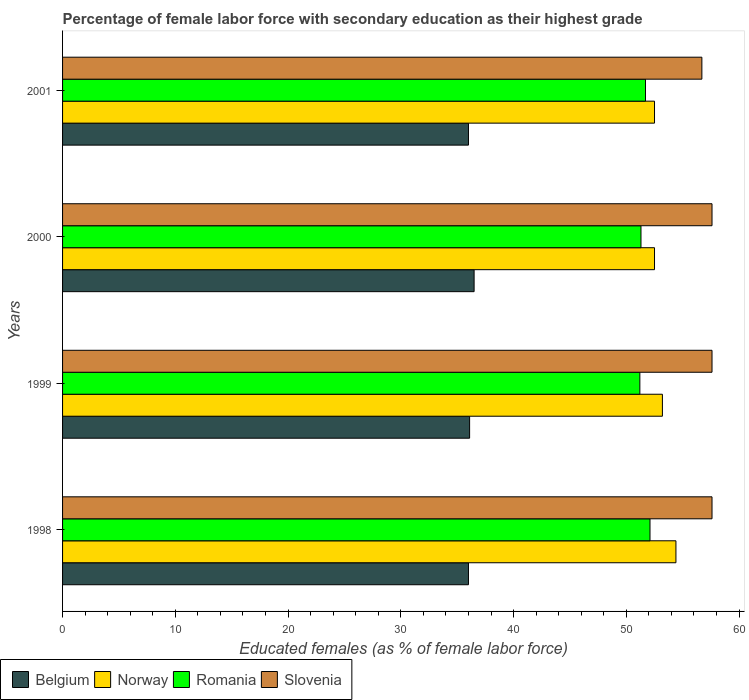How many different coloured bars are there?
Your answer should be very brief. 4. How many groups of bars are there?
Offer a terse response. 4. Are the number of bars per tick equal to the number of legend labels?
Your answer should be very brief. Yes. Are the number of bars on each tick of the Y-axis equal?
Your answer should be very brief. Yes. How many bars are there on the 1st tick from the top?
Your response must be concise. 4. How many bars are there on the 4th tick from the bottom?
Your answer should be compact. 4. What is the label of the 1st group of bars from the top?
Make the answer very short. 2001. In how many cases, is the number of bars for a given year not equal to the number of legend labels?
Keep it short and to the point. 0. What is the percentage of female labor force with secondary education in Romania in 1998?
Keep it short and to the point. 52.1. Across all years, what is the maximum percentage of female labor force with secondary education in Romania?
Make the answer very short. 52.1. Across all years, what is the minimum percentage of female labor force with secondary education in Slovenia?
Provide a short and direct response. 56.7. What is the total percentage of female labor force with secondary education in Romania in the graph?
Your answer should be very brief. 206.3. What is the difference between the percentage of female labor force with secondary education in Norway in 1999 and that in 2000?
Give a very brief answer. 0.7. What is the average percentage of female labor force with secondary education in Romania per year?
Give a very brief answer. 51.57. In the year 1999, what is the difference between the percentage of female labor force with secondary education in Romania and percentage of female labor force with secondary education in Norway?
Your answer should be compact. -2. In how many years, is the percentage of female labor force with secondary education in Romania greater than 40 %?
Provide a succinct answer. 4. What is the ratio of the percentage of female labor force with secondary education in Slovenia in 1999 to that in 2001?
Your answer should be compact. 1.02. Is the percentage of female labor force with secondary education in Norway in 1998 less than that in 2000?
Your answer should be very brief. No. Is the difference between the percentage of female labor force with secondary education in Romania in 1998 and 2001 greater than the difference between the percentage of female labor force with secondary education in Norway in 1998 and 2001?
Your response must be concise. No. What is the difference between the highest and the second highest percentage of female labor force with secondary education in Romania?
Offer a terse response. 0.4. What is the difference between the highest and the lowest percentage of female labor force with secondary education in Belgium?
Keep it short and to the point. 0.5. In how many years, is the percentage of female labor force with secondary education in Romania greater than the average percentage of female labor force with secondary education in Romania taken over all years?
Give a very brief answer. 2. Is the sum of the percentage of female labor force with secondary education in Belgium in 2000 and 2001 greater than the maximum percentage of female labor force with secondary education in Norway across all years?
Provide a short and direct response. Yes. What does the 4th bar from the bottom in 1998 represents?
Your answer should be compact. Slovenia. Are all the bars in the graph horizontal?
Keep it short and to the point. Yes. How many years are there in the graph?
Ensure brevity in your answer.  4. Are the values on the major ticks of X-axis written in scientific E-notation?
Make the answer very short. No. Does the graph contain any zero values?
Make the answer very short. No. Where does the legend appear in the graph?
Your answer should be compact. Bottom left. How many legend labels are there?
Your answer should be very brief. 4. What is the title of the graph?
Your answer should be very brief. Percentage of female labor force with secondary education as their highest grade. Does "St. Kitts and Nevis" appear as one of the legend labels in the graph?
Keep it short and to the point. No. What is the label or title of the X-axis?
Provide a succinct answer. Educated females (as % of female labor force). What is the label or title of the Y-axis?
Make the answer very short. Years. What is the Educated females (as % of female labor force) in Belgium in 1998?
Your answer should be very brief. 36. What is the Educated females (as % of female labor force) in Norway in 1998?
Offer a terse response. 54.4. What is the Educated females (as % of female labor force) of Romania in 1998?
Give a very brief answer. 52.1. What is the Educated females (as % of female labor force) of Slovenia in 1998?
Provide a short and direct response. 57.6. What is the Educated females (as % of female labor force) of Belgium in 1999?
Your answer should be very brief. 36.1. What is the Educated females (as % of female labor force) in Norway in 1999?
Make the answer very short. 53.2. What is the Educated females (as % of female labor force) in Romania in 1999?
Your response must be concise. 51.2. What is the Educated females (as % of female labor force) in Slovenia in 1999?
Provide a short and direct response. 57.6. What is the Educated females (as % of female labor force) of Belgium in 2000?
Offer a terse response. 36.5. What is the Educated females (as % of female labor force) of Norway in 2000?
Your response must be concise. 52.5. What is the Educated females (as % of female labor force) in Romania in 2000?
Your response must be concise. 51.3. What is the Educated females (as % of female labor force) in Slovenia in 2000?
Your answer should be compact. 57.6. What is the Educated females (as % of female labor force) of Norway in 2001?
Make the answer very short. 52.5. What is the Educated females (as % of female labor force) of Romania in 2001?
Your answer should be compact. 51.7. What is the Educated females (as % of female labor force) of Slovenia in 2001?
Ensure brevity in your answer.  56.7. Across all years, what is the maximum Educated females (as % of female labor force) of Belgium?
Give a very brief answer. 36.5. Across all years, what is the maximum Educated females (as % of female labor force) in Norway?
Your answer should be compact. 54.4. Across all years, what is the maximum Educated females (as % of female labor force) in Romania?
Make the answer very short. 52.1. Across all years, what is the maximum Educated females (as % of female labor force) in Slovenia?
Your response must be concise. 57.6. Across all years, what is the minimum Educated females (as % of female labor force) of Belgium?
Provide a short and direct response. 36. Across all years, what is the minimum Educated females (as % of female labor force) of Norway?
Ensure brevity in your answer.  52.5. Across all years, what is the minimum Educated females (as % of female labor force) in Romania?
Your response must be concise. 51.2. Across all years, what is the minimum Educated females (as % of female labor force) in Slovenia?
Offer a terse response. 56.7. What is the total Educated females (as % of female labor force) of Belgium in the graph?
Provide a succinct answer. 144.6. What is the total Educated females (as % of female labor force) in Norway in the graph?
Make the answer very short. 212.6. What is the total Educated females (as % of female labor force) of Romania in the graph?
Keep it short and to the point. 206.3. What is the total Educated females (as % of female labor force) in Slovenia in the graph?
Give a very brief answer. 229.5. What is the difference between the Educated females (as % of female labor force) in Romania in 1998 and that in 1999?
Your response must be concise. 0.9. What is the difference between the Educated females (as % of female labor force) of Norway in 1998 and that in 2000?
Make the answer very short. 1.9. What is the difference between the Educated females (as % of female labor force) of Romania in 1998 and that in 2000?
Ensure brevity in your answer.  0.8. What is the difference between the Educated females (as % of female labor force) of Belgium in 1998 and that in 2001?
Your answer should be very brief. 0. What is the difference between the Educated females (as % of female labor force) in Slovenia in 1998 and that in 2001?
Provide a short and direct response. 0.9. What is the difference between the Educated females (as % of female labor force) in Romania in 1999 and that in 2000?
Provide a short and direct response. -0.1. What is the difference between the Educated females (as % of female labor force) in Norway in 1999 and that in 2001?
Give a very brief answer. 0.7. What is the difference between the Educated females (as % of female labor force) of Romania in 1999 and that in 2001?
Offer a terse response. -0.5. What is the difference between the Educated females (as % of female labor force) of Slovenia in 2000 and that in 2001?
Your answer should be compact. 0.9. What is the difference between the Educated females (as % of female labor force) in Belgium in 1998 and the Educated females (as % of female labor force) in Norway in 1999?
Give a very brief answer. -17.2. What is the difference between the Educated females (as % of female labor force) in Belgium in 1998 and the Educated females (as % of female labor force) in Romania in 1999?
Offer a very short reply. -15.2. What is the difference between the Educated females (as % of female labor force) in Belgium in 1998 and the Educated females (as % of female labor force) in Slovenia in 1999?
Offer a very short reply. -21.6. What is the difference between the Educated females (as % of female labor force) in Norway in 1998 and the Educated females (as % of female labor force) in Slovenia in 1999?
Your response must be concise. -3.2. What is the difference between the Educated females (as % of female labor force) in Belgium in 1998 and the Educated females (as % of female labor force) in Norway in 2000?
Give a very brief answer. -16.5. What is the difference between the Educated females (as % of female labor force) of Belgium in 1998 and the Educated females (as % of female labor force) of Romania in 2000?
Offer a very short reply. -15.3. What is the difference between the Educated females (as % of female labor force) of Belgium in 1998 and the Educated females (as % of female labor force) of Slovenia in 2000?
Offer a very short reply. -21.6. What is the difference between the Educated females (as % of female labor force) of Norway in 1998 and the Educated females (as % of female labor force) of Romania in 2000?
Make the answer very short. 3.1. What is the difference between the Educated females (as % of female labor force) of Romania in 1998 and the Educated females (as % of female labor force) of Slovenia in 2000?
Your response must be concise. -5.5. What is the difference between the Educated females (as % of female labor force) in Belgium in 1998 and the Educated females (as % of female labor force) in Norway in 2001?
Make the answer very short. -16.5. What is the difference between the Educated females (as % of female labor force) in Belgium in 1998 and the Educated females (as % of female labor force) in Romania in 2001?
Provide a succinct answer. -15.7. What is the difference between the Educated females (as % of female labor force) in Belgium in 1998 and the Educated females (as % of female labor force) in Slovenia in 2001?
Make the answer very short. -20.7. What is the difference between the Educated females (as % of female labor force) of Belgium in 1999 and the Educated females (as % of female labor force) of Norway in 2000?
Ensure brevity in your answer.  -16.4. What is the difference between the Educated females (as % of female labor force) of Belgium in 1999 and the Educated females (as % of female labor force) of Romania in 2000?
Ensure brevity in your answer.  -15.2. What is the difference between the Educated females (as % of female labor force) in Belgium in 1999 and the Educated females (as % of female labor force) in Slovenia in 2000?
Provide a short and direct response. -21.5. What is the difference between the Educated females (as % of female labor force) in Norway in 1999 and the Educated females (as % of female labor force) in Slovenia in 2000?
Your response must be concise. -4.4. What is the difference between the Educated females (as % of female labor force) in Belgium in 1999 and the Educated females (as % of female labor force) in Norway in 2001?
Keep it short and to the point. -16.4. What is the difference between the Educated females (as % of female labor force) of Belgium in 1999 and the Educated females (as % of female labor force) of Romania in 2001?
Offer a terse response. -15.6. What is the difference between the Educated females (as % of female labor force) in Belgium in 1999 and the Educated females (as % of female labor force) in Slovenia in 2001?
Keep it short and to the point. -20.6. What is the difference between the Educated females (as % of female labor force) in Norway in 1999 and the Educated females (as % of female labor force) in Romania in 2001?
Provide a succinct answer. 1.5. What is the difference between the Educated females (as % of female labor force) in Romania in 1999 and the Educated females (as % of female labor force) in Slovenia in 2001?
Offer a terse response. -5.5. What is the difference between the Educated females (as % of female labor force) of Belgium in 2000 and the Educated females (as % of female labor force) of Norway in 2001?
Offer a very short reply. -16. What is the difference between the Educated females (as % of female labor force) in Belgium in 2000 and the Educated females (as % of female labor force) in Romania in 2001?
Your answer should be very brief. -15.2. What is the difference between the Educated females (as % of female labor force) in Belgium in 2000 and the Educated females (as % of female labor force) in Slovenia in 2001?
Offer a very short reply. -20.2. What is the difference between the Educated females (as % of female labor force) of Norway in 2000 and the Educated females (as % of female labor force) of Romania in 2001?
Provide a short and direct response. 0.8. What is the difference between the Educated females (as % of female labor force) of Romania in 2000 and the Educated females (as % of female labor force) of Slovenia in 2001?
Your answer should be very brief. -5.4. What is the average Educated females (as % of female labor force) in Belgium per year?
Offer a very short reply. 36.15. What is the average Educated females (as % of female labor force) in Norway per year?
Offer a terse response. 53.15. What is the average Educated females (as % of female labor force) in Romania per year?
Keep it short and to the point. 51.58. What is the average Educated females (as % of female labor force) of Slovenia per year?
Provide a succinct answer. 57.38. In the year 1998, what is the difference between the Educated females (as % of female labor force) in Belgium and Educated females (as % of female labor force) in Norway?
Offer a very short reply. -18.4. In the year 1998, what is the difference between the Educated females (as % of female labor force) in Belgium and Educated females (as % of female labor force) in Romania?
Offer a very short reply. -16.1. In the year 1998, what is the difference between the Educated females (as % of female labor force) of Belgium and Educated females (as % of female labor force) of Slovenia?
Your answer should be very brief. -21.6. In the year 1998, what is the difference between the Educated females (as % of female labor force) in Norway and Educated females (as % of female labor force) in Romania?
Give a very brief answer. 2.3. In the year 1999, what is the difference between the Educated females (as % of female labor force) in Belgium and Educated females (as % of female labor force) in Norway?
Your response must be concise. -17.1. In the year 1999, what is the difference between the Educated females (as % of female labor force) of Belgium and Educated females (as % of female labor force) of Romania?
Provide a short and direct response. -15.1. In the year 1999, what is the difference between the Educated females (as % of female labor force) in Belgium and Educated females (as % of female labor force) in Slovenia?
Your answer should be compact. -21.5. In the year 1999, what is the difference between the Educated females (as % of female labor force) in Norway and Educated females (as % of female labor force) in Romania?
Your response must be concise. 2. In the year 1999, what is the difference between the Educated females (as % of female labor force) in Norway and Educated females (as % of female labor force) in Slovenia?
Offer a terse response. -4.4. In the year 1999, what is the difference between the Educated females (as % of female labor force) of Romania and Educated females (as % of female labor force) of Slovenia?
Give a very brief answer. -6.4. In the year 2000, what is the difference between the Educated females (as % of female labor force) of Belgium and Educated females (as % of female labor force) of Norway?
Give a very brief answer. -16. In the year 2000, what is the difference between the Educated females (as % of female labor force) in Belgium and Educated females (as % of female labor force) in Romania?
Offer a very short reply. -14.8. In the year 2000, what is the difference between the Educated females (as % of female labor force) in Belgium and Educated females (as % of female labor force) in Slovenia?
Offer a terse response. -21.1. In the year 2000, what is the difference between the Educated females (as % of female labor force) of Norway and Educated females (as % of female labor force) of Slovenia?
Ensure brevity in your answer.  -5.1. In the year 2001, what is the difference between the Educated females (as % of female labor force) in Belgium and Educated females (as % of female labor force) in Norway?
Offer a terse response. -16.5. In the year 2001, what is the difference between the Educated females (as % of female labor force) in Belgium and Educated females (as % of female labor force) in Romania?
Offer a very short reply. -15.7. In the year 2001, what is the difference between the Educated females (as % of female labor force) of Belgium and Educated females (as % of female labor force) of Slovenia?
Offer a very short reply. -20.7. In the year 2001, what is the difference between the Educated females (as % of female labor force) in Norway and Educated females (as % of female labor force) in Slovenia?
Keep it short and to the point. -4.2. In the year 2001, what is the difference between the Educated females (as % of female labor force) of Romania and Educated females (as % of female labor force) of Slovenia?
Offer a very short reply. -5. What is the ratio of the Educated females (as % of female labor force) in Norway in 1998 to that in 1999?
Give a very brief answer. 1.02. What is the ratio of the Educated females (as % of female labor force) of Romania in 1998 to that in 1999?
Give a very brief answer. 1.02. What is the ratio of the Educated females (as % of female labor force) in Slovenia in 1998 to that in 1999?
Offer a terse response. 1. What is the ratio of the Educated females (as % of female labor force) in Belgium in 1998 to that in 2000?
Give a very brief answer. 0.99. What is the ratio of the Educated females (as % of female labor force) in Norway in 1998 to that in 2000?
Your answer should be compact. 1.04. What is the ratio of the Educated females (as % of female labor force) of Romania in 1998 to that in 2000?
Offer a very short reply. 1.02. What is the ratio of the Educated females (as % of female labor force) in Slovenia in 1998 to that in 2000?
Make the answer very short. 1. What is the ratio of the Educated females (as % of female labor force) in Belgium in 1998 to that in 2001?
Give a very brief answer. 1. What is the ratio of the Educated females (as % of female labor force) of Norway in 1998 to that in 2001?
Give a very brief answer. 1.04. What is the ratio of the Educated females (as % of female labor force) in Romania in 1998 to that in 2001?
Provide a succinct answer. 1.01. What is the ratio of the Educated females (as % of female labor force) in Slovenia in 1998 to that in 2001?
Give a very brief answer. 1.02. What is the ratio of the Educated females (as % of female labor force) of Norway in 1999 to that in 2000?
Provide a short and direct response. 1.01. What is the ratio of the Educated females (as % of female labor force) of Romania in 1999 to that in 2000?
Provide a short and direct response. 1. What is the ratio of the Educated females (as % of female labor force) of Norway in 1999 to that in 2001?
Provide a short and direct response. 1.01. What is the ratio of the Educated females (as % of female labor force) in Romania in 1999 to that in 2001?
Ensure brevity in your answer.  0.99. What is the ratio of the Educated females (as % of female labor force) in Slovenia in 1999 to that in 2001?
Keep it short and to the point. 1.02. What is the ratio of the Educated females (as % of female labor force) of Belgium in 2000 to that in 2001?
Keep it short and to the point. 1.01. What is the ratio of the Educated females (as % of female labor force) in Norway in 2000 to that in 2001?
Give a very brief answer. 1. What is the ratio of the Educated females (as % of female labor force) of Slovenia in 2000 to that in 2001?
Your response must be concise. 1.02. What is the difference between the highest and the second highest Educated females (as % of female labor force) of Belgium?
Your answer should be compact. 0.4. What is the difference between the highest and the second highest Educated females (as % of female labor force) in Norway?
Give a very brief answer. 1.2. What is the difference between the highest and the second highest Educated females (as % of female labor force) in Romania?
Offer a terse response. 0.4. What is the difference between the highest and the lowest Educated females (as % of female labor force) in Romania?
Provide a succinct answer. 0.9. 